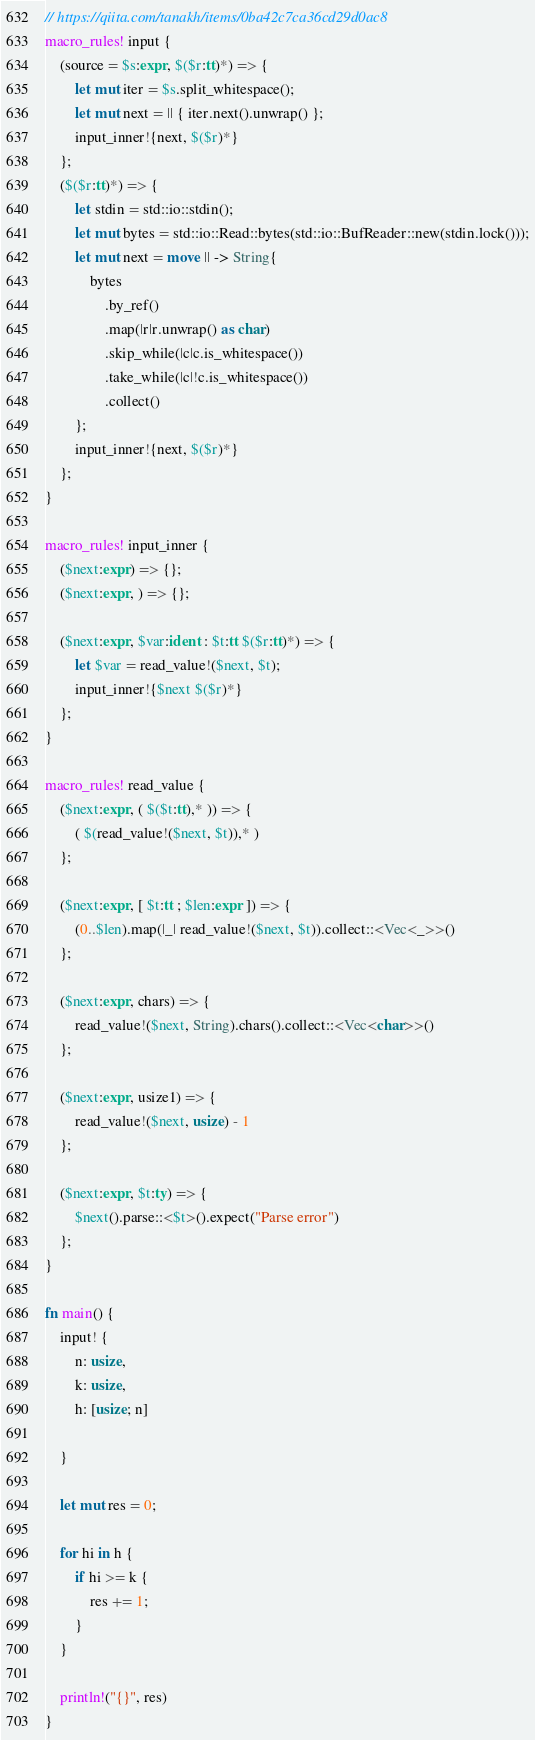<code> <loc_0><loc_0><loc_500><loc_500><_Rust_>// https://qiita.com/tanakh/items/0ba42c7ca36cd29d0ac8
macro_rules! input {
    (source = $s:expr, $($r:tt)*) => {
        let mut iter = $s.split_whitespace();
        let mut next = || { iter.next().unwrap() };
        input_inner!{next, $($r)*}
    };
    ($($r:tt)*) => {
        let stdin = std::io::stdin();
        let mut bytes = std::io::Read::bytes(std::io::BufReader::new(stdin.lock()));
        let mut next = move || -> String{
            bytes
                .by_ref()
                .map(|r|r.unwrap() as char)
                .skip_while(|c|c.is_whitespace())
                .take_while(|c|!c.is_whitespace())
                .collect()
        };
        input_inner!{next, $($r)*}
    };
}

macro_rules! input_inner {
    ($next:expr) => {};
    ($next:expr, ) => {};

    ($next:expr, $var:ident : $t:tt $($r:tt)*) => {
        let $var = read_value!($next, $t);
        input_inner!{$next $($r)*}
    };
}

macro_rules! read_value {
    ($next:expr, ( $($t:tt),* )) => {
        ( $(read_value!($next, $t)),* )
    };

    ($next:expr, [ $t:tt ; $len:expr ]) => {
        (0..$len).map(|_| read_value!($next, $t)).collect::<Vec<_>>()
    };

    ($next:expr, chars) => {
        read_value!($next, String).chars().collect::<Vec<char>>()
    };

    ($next:expr, usize1) => {
        read_value!($next, usize) - 1
    };

    ($next:expr, $t:ty) => {
        $next().parse::<$t>().expect("Parse error")
    };
}

fn main() {
    input! {
        n: usize,
        k: usize,
        h: [usize; n]

    }

    let mut res = 0;

    for hi in h {
        if hi >= k {
            res += 1;
        }
    }

    println!("{}", res)
}</code> 